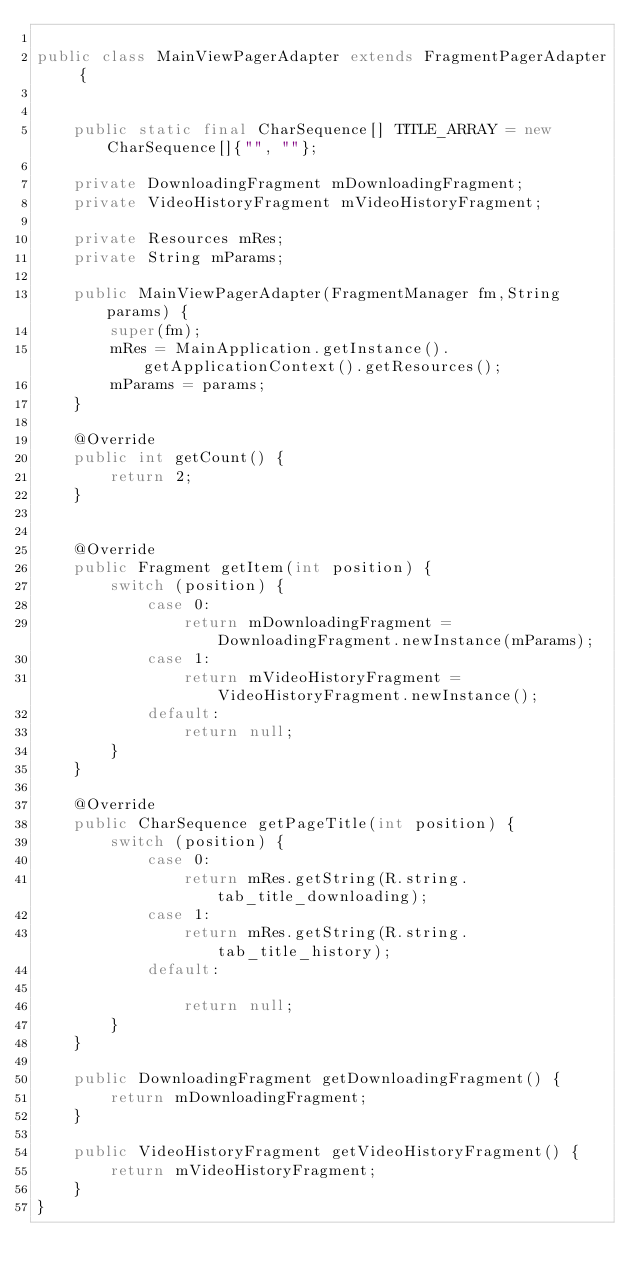Convert code to text. <code><loc_0><loc_0><loc_500><loc_500><_Java_>
public class MainViewPagerAdapter extends FragmentPagerAdapter {


    public static final CharSequence[] TITLE_ARRAY = new CharSequence[]{"", ""};

    private DownloadingFragment mDownloadingFragment;
    private VideoHistoryFragment mVideoHistoryFragment;

    private Resources mRes;
    private String mParams;

    public MainViewPagerAdapter(FragmentManager fm,String params) {
        super(fm);
        mRes = MainApplication.getInstance().getApplicationContext().getResources();
        mParams = params;
    }

    @Override
    public int getCount() {
        return 2;
    }


    @Override
    public Fragment getItem(int position) {
        switch (position) {
            case 0:
                return mDownloadingFragment = DownloadingFragment.newInstance(mParams);
            case 1:
                return mVideoHistoryFragment = VideoHistoryFragment.newInstance();
            default:
                return null;
        }
    }

    @Override
    public CharSequence getPageTitle(int position) {
        switch (position) {
            case 0:
                return mRes.getString(R.string.tab_title_downloading);
            case 1:
                return mRes.getString(R.string.tab_title_history);
            default:

                return null;
        }
    }

    public DownloadingFragment getDownloadingFragment() {
        return mDownloadingFragment;
    }

    public VideoHistoryFragment getVideoHistoryFragment() {
        return mVideoHistoryFragment;
    }
}
</code> 